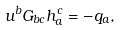Convert formula to latex. <formula><loc_0><loc_0><loc_500><loc_500>u ^ { b } G _ { b c } h ^ { c } _ { a } = - q _ { a } ,</formula> 